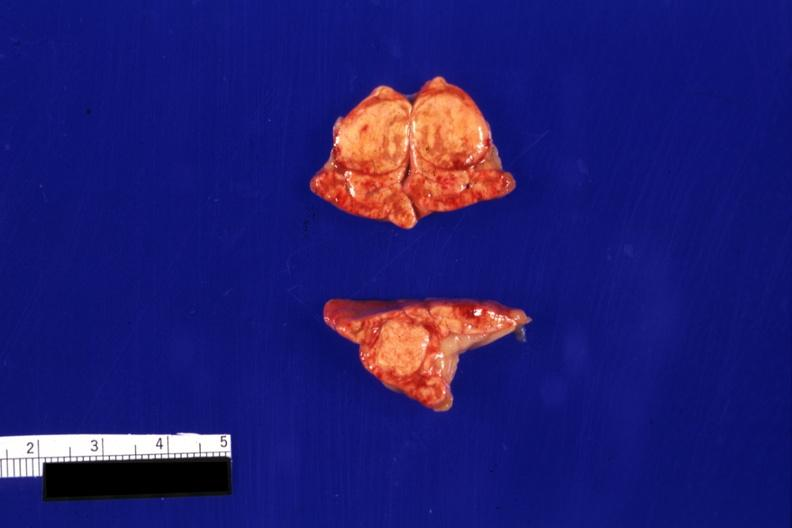what is present?
Answer the question using a single word or phrase. Nodule 